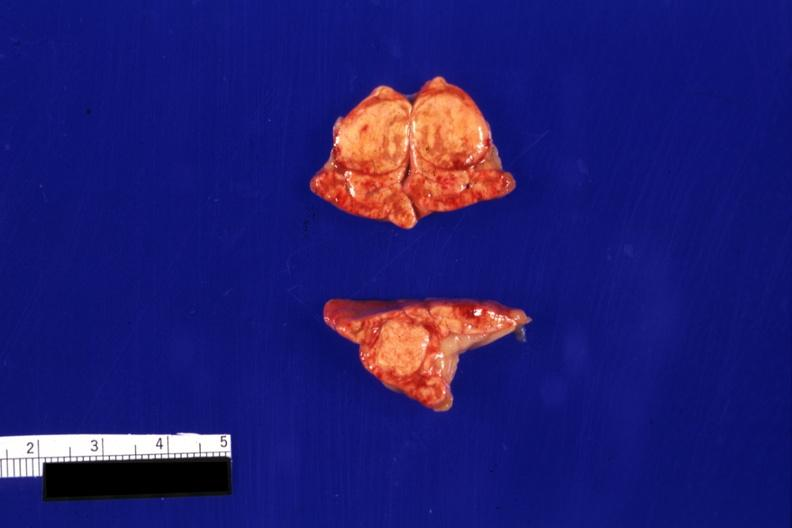what is present?
Answer the question using a single word or phrase. Nodule 